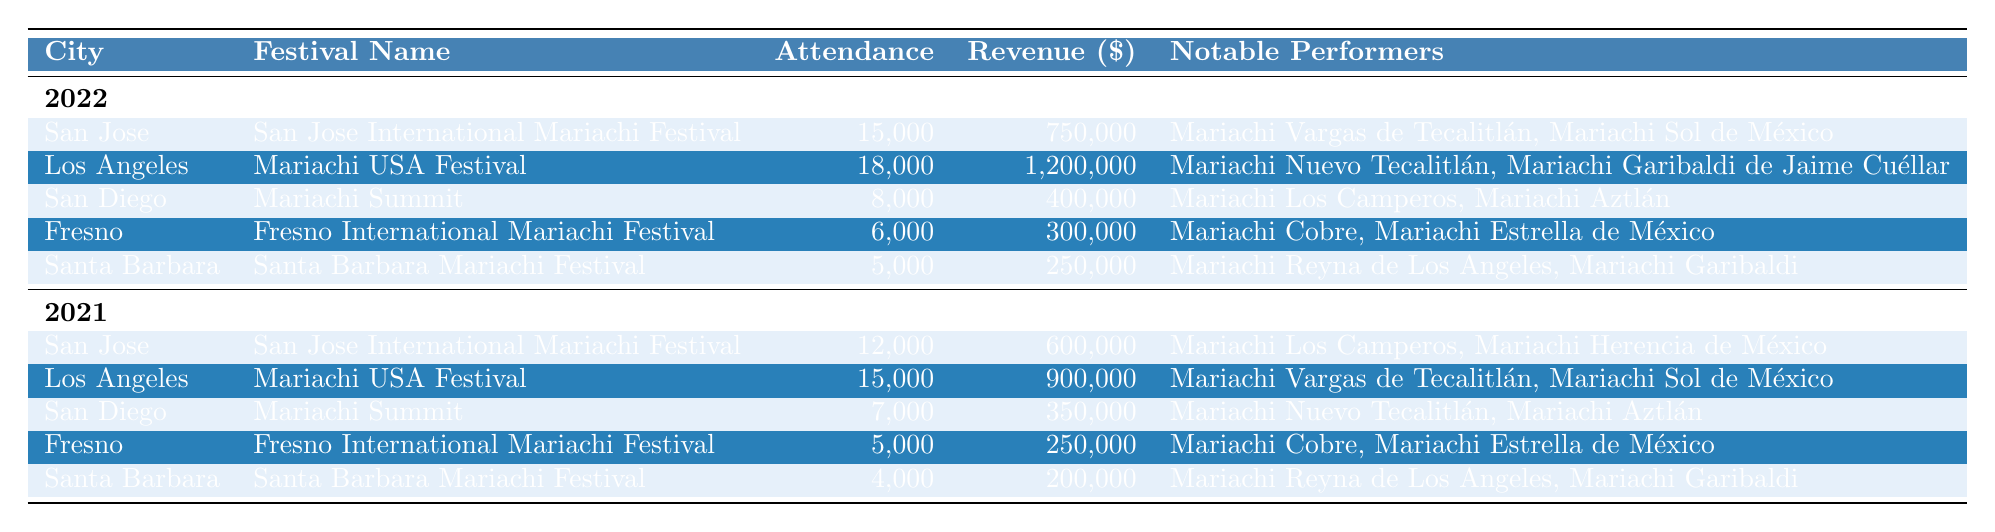What was the highest attendance at a mariachi festival in California in 2022? According to the table, the highest attendance in 2022 was at the Los Angeles Mariachi USA Festival with 18,000 attendees.
Answer: 18,000 Which city hosted the Fresno International Mariachi Festival in 2021? The table indicates that the Fresno International Mariachi Festival took place in Fresno in 2021.
Answer: Fresno What is the total revenue generated by the San Jose International Mariachi Festival across both years? The revenue for the San Jose International Mariachi Festival in 2022 is $750,000 and in 2021 is $600,000. Adding these gives $750,000 + $600,000 = $1,350,000.
Answer: $1,350,000 Did Santa Barbara have a higher attendance in 2022 compared to 2021? The table shows Santa Barbara had an attendance of 5,000 in 2022 and 4,000 in 2021. Since 5,000 is greater than 4,000, the answer is yes.
Answer: Yes What is the average attendance across all festivals in 2022? To find the average attendance in 2022, we add the attendance figures for each festival: 15,000 (San Jose) + 18,000 (Los Angeles) + 8,000 (San Diego) + 6,000 (Fresno) + 5,000 (Santa Barbara) = 52,000. There are 5 festivals, so the average is 52,000 / 5 = 10,400.
Answer: 10,400 Which notable performers appeared at the San Diego Mariachi Summit in 2021? The table lists that the notable performers at the San Diego Mariachi Summit in 2021 were Mariachi Nuevo Tecalitlán and Mariachi Aztlán.
Answer: Mariachi Nuevo Tecalitlán, Mariachi Aztlán What was the difference in revenue for the San Jose International Mariachi Festival between 2021 and 2022? The revenue for 2022 is $750,000 and for 2021 is $600,000. The difference is $750,000 - $600,000 = $150,000.
Answer: $150,000 Is the total revenue for all festivals in 2021 greater than that in 2022? First, we sum up the revenues from each year: in 2021, it's $600,000 + $900,000 + $350,000 + $250,000 + $200,000 = $2,300,000, and in 2022 it's $750,000 + $1,200,000 + $400,000 + $300,000 + $250,000 = $2,900,000. Since $2,300,000 is less than $2,900,000, the answer is no.
Answer: No What was the festival with the lowest attendance in 2021 and how many attendees were there? The table shows that the Santa Barbara Mariachi Festival had the lowest attendance in 2021, with only 4,000 attendees.
Answer: 4,000 Which festival had the highest revenue in 2021? The table indicates that the highest revenue in 2021 was from the Los Angeles Mariachi USA Festival, which generated $900,000.
Answer: $900,000 